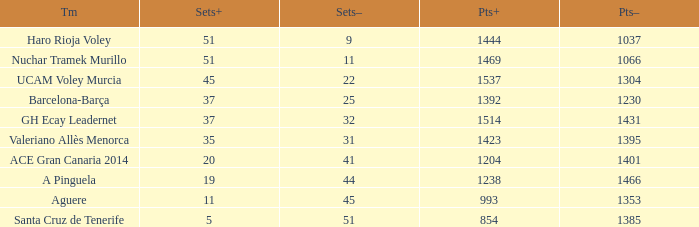Who is the team who had a Sets+ number smaller than 20, a Sets- number of 45, and a Points+ number smaller than 1238? Aguere. 